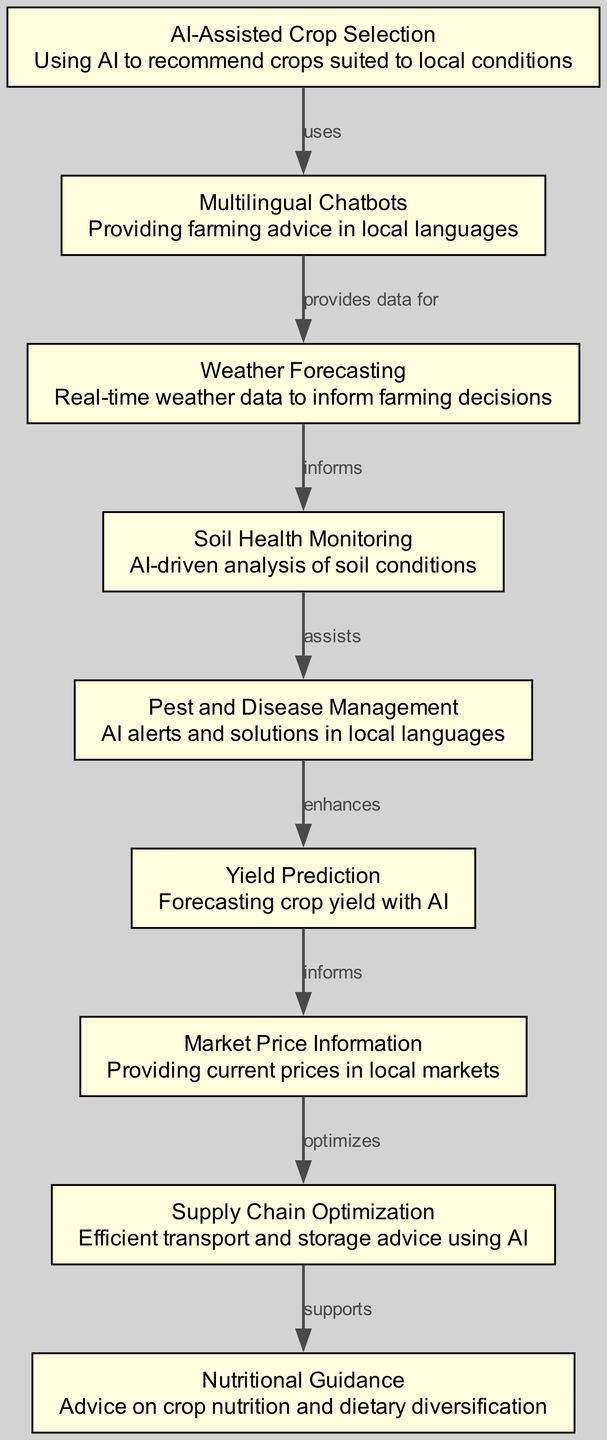What is the first node in the food chain? The first node is "AI-Assisted Crop Selection," which represents the initial stage of using AI for crop recommendations.
Answer: AI-Assisted Crop Selection How many nodes are there in the diagram? By counting each unique entry under "nodes," we see there are a total of 9 nodes in the diagram.
Answer: 9 Which node provides advice in local languages? The node that provides farming advice in local languages is "Multilingual Chatbots."
Answer: Multilingual Chatbots What relationship does "Weather Forecasting" have with another node? "Weather Forecasting" is informed by "Multilingual Chatbots" as indicated in the edges describing their connection.
Answer: informs Which node enhances "Yield Prediction"? The node that enhances "Yield Prediction" is "Pest and Disease Management," showing the flow of information from pest management to yield outcomes.
Answer: Pest and Disease Management What supports "Nutritional Guidance"? The node that supports "Nutritional Guidance" is "Supply Chain Optimization," as per the flow of advice leading towards nutritional support.
Answer: Supply Chain Optimization How does "Soil Health Monitoring" assist another node? "Soil Health Monitoring" assists "Pest and Disease Management," indicating that insights into soil health are beneficial for managing pests and diseases.
Answer: assists What optimizes market price information? Market price information is optimized by "Supply Chain Optimization," reflecting how understanding logistics can influence market prices.
Answer: Supply Chain Optimization Which node is connected to "Market Price Information" and how? "Yield Prediction" is connected to "Market Price Information," as it informs market prices by forecasting crop yields.
Answer: informs 